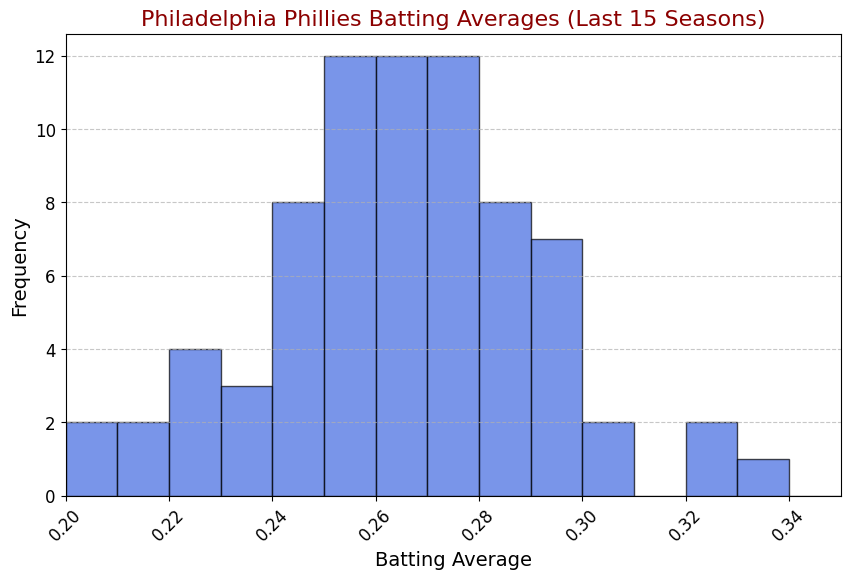What is the most common batting average range for Philadelphia Phillies players over the last 15 seasons? To identify the most common batting average range, look for the tallest bar in the histogram. The tallest bar indicates the range with the highest frequency.
Answer: 0.25 - 0.26 How does the frequency of batting averages between 0.29 and 0.30 compare to those between 0.20 and 0.21? Count the number of batting averages in each range by looking at the height of the corresponding bars in the histogram.
Answer: 0.29-0.30 is higher What is the total number of players with a batting average between 0.27 and 0.28? Summing the heights of the bars between the ranges 0.27 and 0.28 on the x-axis will give the total frequency of batting averages in this range.
Answer: 8 Which range has the lowest batting average observed in the data set? Look for the first x-axis label (bin range) that has at least one visible bar, indicating the lowest batting average range.
Answer: 0.20 - 0.21 Compare the frequency of batting averages below 0.24 with those above 0.30. Which is more common? Count the number of bars below 0.24 and sum their frequencies, then do the same for the bars above 0.30 and compare the totals.
Answer: Below 0.24 is more common How many players had a batting average in the range 0.32 to 0.33? Find the bar that corresponds to the range 0.32 to 0.33 and read off its height to determine the number of players.
Answer: 2 Is the frequency of batting averages between 0.26 and 0.28 higher or lower than the frequency between 0.28 and 0.30? Sum the heights of the bars within the 0.26-0.28 range and compare it to the sum of the heights within the 0.28-0.30 range.
Answer: Higher What percentage of players had a batting average between 0.22 and 0.23? Find the bar associated with the range 0.22-0.23 and note its frequency, then divide by the total number of players and multiply by 100 to get the percentage.
Answer: 6.6% What is the median batting average range for the players? Identify the range which divides the histogram such that half of the players have batting averages below this range and half above. This can be done by visually splitting the total frequency in half.
Answer: 0.26 - 0.27 How does the batting average distribution indicate the overall performance consistency among the players? Assess the spread and concentration of the bars; a narrow range with tall bars at the center indicates consistency, while a wide spread with short, dispersed bars suggests variability.
Answer: Moderately consistent with some variability 